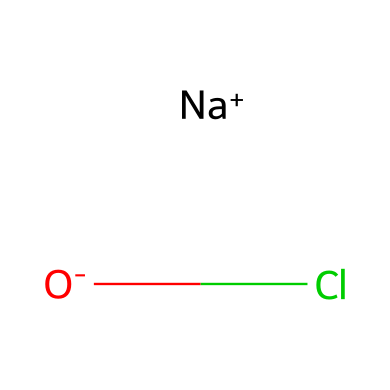What is the molecular formula of this compound? The SMILES representation shows one sodium atom (Na), one oxygen atom (O), and one chlorine atom (Cl). Combined, these elements form the molecular formula NaOCl.
Answer: NaOCl How many bonds are indicated in the chemical structure? The SMILES representation contains one bond between the oxygen and chlorine atoms (O-Cl) and an ionic interaction between sodium and oxygen. Thus, there is one covalent bond.
Answer: 1 What type of compound is sodium hypochlorite classified as? Sodium hypochlorite contains chlorine and oxygen, which classifies it as an oxidizing agent due to its ability to accept electrons during chemical reactions.
Answer: oxidizing agent What is the oxidation state of chlorine in this compound? In the chemical formula NaOCl, oxygen typically has an oxidation state of -2. Therefore, to balance the charges for the overall neutral compound, chlorine must have an oxidation state of +1.
Answer: +1 How many atoms are present in this chemical structure? The SMILES representation reveals three distinct atoms: one sodium (Na), one oxygen (O), and one chlorine (Cl), totaling three atoms.
Answer: 3 What role does sodium play in sodium hypochlorite? Sodium serves as a counterion to balance the negative charge of the hypochlorite ion (OCl-), thus contributing to the compound's stability and solubility in water.
Answer: counterion 